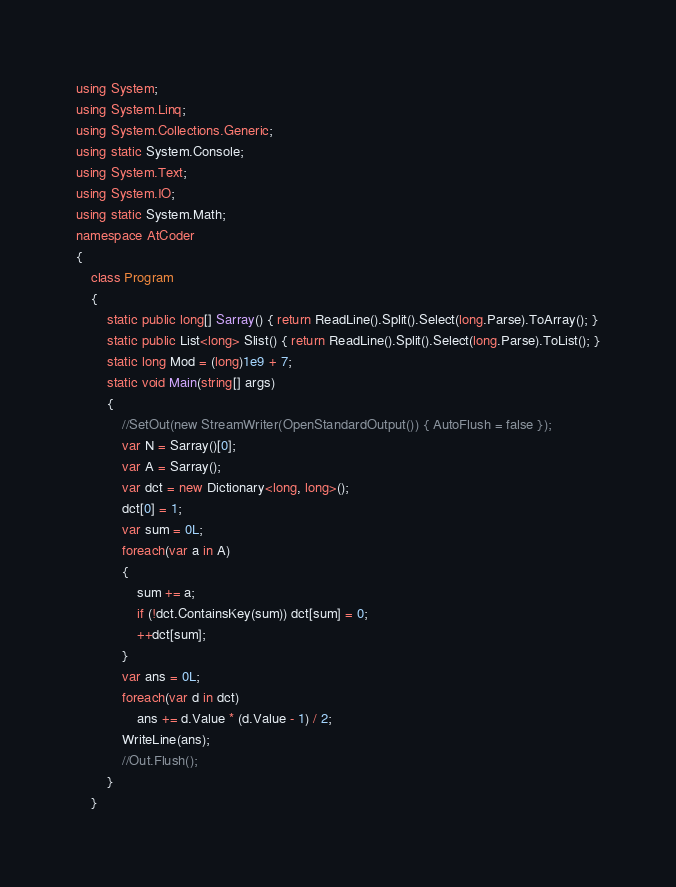<code> <loc_0><loc_0><loc_500><loc_500><_C#_>using System;
using System.Linq;
using System.Collections.Generic;
using static System.Console;
using System.Text;
using System.IO;
using static System.Math;
namespace AtCoder
{
    class Program
    {
        static public long[] Sarray() { return ReadLine().Split().Select(long.Parse).ToArray(); }
        static public List<long> Slist() { return ReadLine().Split().Select(long.Parse).ToList(); }
        static long Mod = (long)1e9 + 7;
        static void Main(string[] args)
        {
            //SetOut(new StreamWriter(OpenStandardOutput()) { AutoFlush = false });
            var N = Sarray()[0];
            var A = Sarray();
            var dct = new Dictionary<long, long>();
            dct[0] = 1;
            var sum = 0L;
            foreach(var a in A)
            {
                sum += a;
                if (!dct.ContainsKey(sum)) dct[sum] = 0;
                ++dct[sum];
            }
            var ans = 0L;
            foreach(var d in dct)
                ans += d.Value * (d.Value - 1) / 2;
            WriteLine(ans);
            //Out.Flush();
        }
    }
</code> 